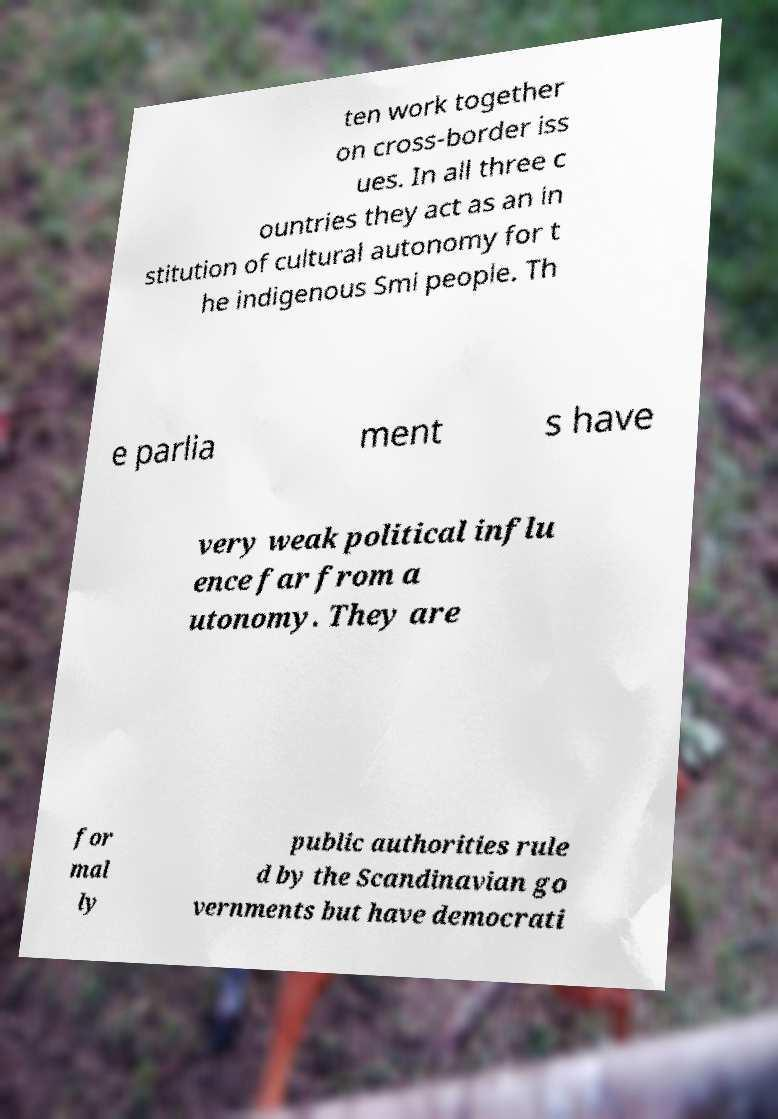Can you accurately transcribe the text from the provided image for me? ten work together on cross-border iss ues. In all three c ountries they act as an in stitution of cultural autonomy for t he indigenous Smi people. Th e parlia ment s have very weak political influ ence far from a utonomy. They are for mal ly public authorities rule d by the Scandinavian go vernments but have democrati 